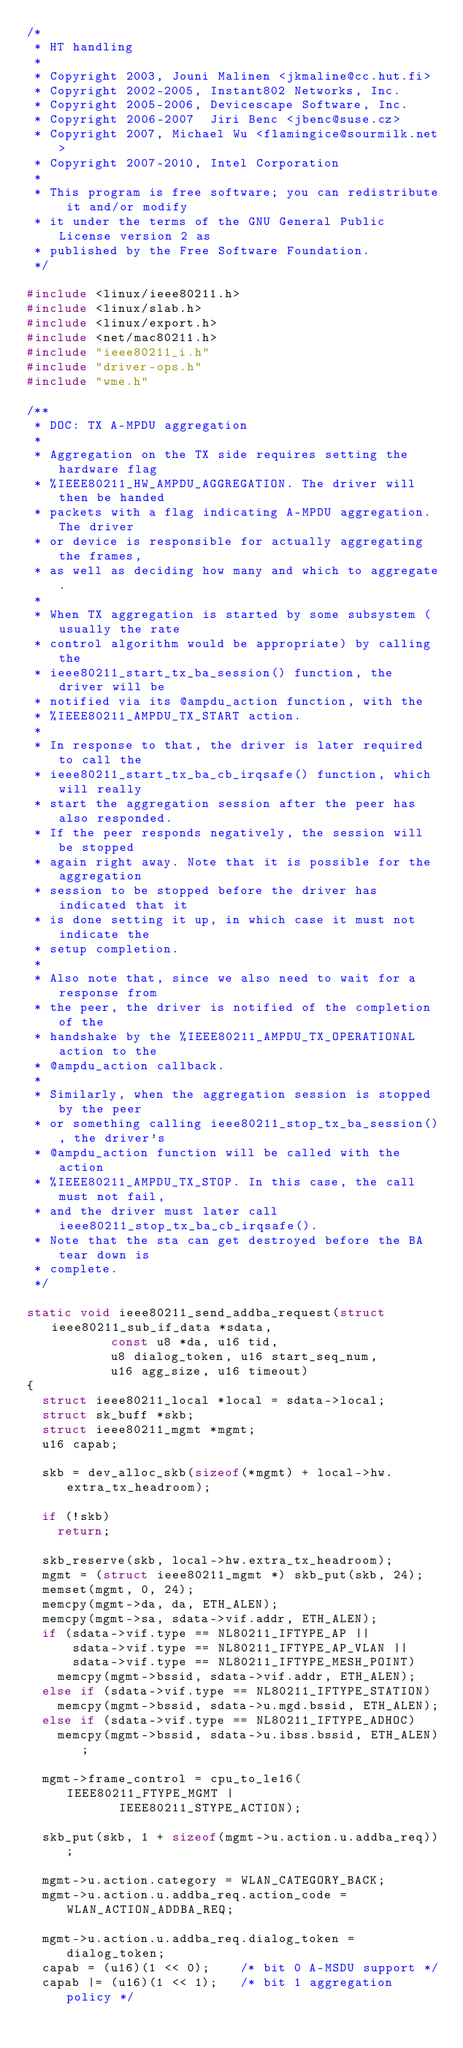<code> <loc_0><loc_0><loc_500><loc_500><_C_>/*
 * HT handling
 *
 * Copyright 2003, Jouni Malinen <jkmaline@cc.hut.fi>
 * Copyright 2002-2005, Instant802 Networks, Inc.
 * Copyright 2005-2006, Devicescape Software, Inc.
 * Copyright 2006-2007	Jiri Benc <jbenc@suse.cz>
 * Copyright 2007, Michael Wu <flamingice@sourmilk.net>
 * Copyright 2007-2010, Intel Corporation
 *
 * This program is free software; you can redistribute it and/or modify
 * it under the terms of the GNU General Public License version 2 as
 * published by the Free Software Foundation.
 */

#include <linux/ieee80211.h>
#include <linux/slab.h>
#include <linux/export.h>
#include <net/mac80211.h>
#include "ieee80211_i.h"
#include "driver-ops.h"
#include "wme.h"

/**
 * DOC: TX A-MPDU aggregation
 *
 * Aggregation on the TX side requires setting the hardware flag
 * %IEEE80211_HW_AMPDU_AGGREGATION. The driver will then be handed
 * packets with a flag indicating A-MPDU aggregation. The driver
 * or device is responsible for actually aggregating the frames,
 * as well as deciding how many and which to aggregate.
 *
 * When TX aggregation is started by some subsystem (usually the rate
 * control algorithm would be appropriate) by calling the
 * ieee80211_start_tx_ba_session() function, the driver will be
 * notified via its @ampdu_action function, with the
 * %IEEE80211_AMPDU_TX_START action.
 *
 * In response to that, the driver is later required to call the
 * ieee80211_start_tx_ba_cb_irqsafe() function, which will really
 * start the aggregation session after the peer has also responded.
 * If the peer responds negatively, the session will be stopped
 * again right away. Note that it is possible for the aggregation
 * session to be stopped before the driver has indicated that it
 * is done setting it up, in which case it must not indicate the
 * setup completion.
 *
 * Also note that, since we also need to wait for a response from
 * the peer, the driver is notified of the completion of the
 * handshake by the %IEEE80211_AMPDU_TX_OPERATIONAL action to the
 * @ampdu_action callback.
 *
 * Similarly, when the aggregation session is stopped by the peer
 * or something calling ieee80211_stop_tx_ba_session(), the driver's
 * @ampdu_action function will be called with the action
 * %IEEE80211_AMPDU_TX_STOP. In this case, the call must not fail,
 * and the driver must later call ieee80211_stop_tx_ba_cb_irqsafe().
 * Note that the sta can get destroyed before the BA tear down is
 * complete.
 */

static void ieee80211_send_addba_request(struct ieee80211_sub_if_data *sdata,
					 const u8 *da, u16 tid,
					 u8 dialog_token, u16 start_seq_num,
					 u16 agg_size, u16 timeout)
{
	struct ieee80211_local *local = sdata->local;
	struct sk_buff *skb;
	struct ieee80211_mgmt *mgmt;
	u16 capab;

	skb = dev_alloc_skb(sizeof(*mgmt) + local->hw.extra_tx_headroom);

	if (!skb)
		return;

	skb_reserve(skb, local->hw.extra_tx_headroom);
	mgmt = (struct ieee80211_mgmt *) skb_put(skb, 24);
	memset(mgmt, 0, 24);
	memcpy(mgmt->da, da, ETH_ALEN);
	memcpy(mgmt->sa, sdata->vif.addr, ETH_ALEN);
	if (sdata->vif.type == NL80211_IFTYPE_AP ||
	    sdata->vif.type == NL80211_IFTYPE_AP_VLAN ||
	    sdata->vif.type == NL80211_IFTYPE_MESH_POINT)
		memcpy(mgmt->bssid, sdata->vif.addr, ETH_ALEN);
	else if (sdata->vif.type == NL80211_IFTYPE_STATION)
		memcpy(mgmt->bssid, sdata->u.mgd.bssid, ETH_ALEN);
	else if (sdata->vif.type == NL80211_IFTYPE_ADHOC)
		memcpy(mgmt->bssid, sdata->u.ibss.bssid, ETH_ALEN);

	mgmt->frame_control = cpu_to_le16(IEEE80211_FTYPE_MGMT |
					  IEEE80211_STYPE_ACTION);

	skb_put(skb, 1 + sizeof(mgmt->u.action.u.addba_req));

	mgmt->u.action.category = WLAN_CATEGORY_BACK;
	mgmt->u.action.u.addba_req.action_code = WLAN_ACTION_ADDBA_REQ;

	mgmt->u.action.u.addba_req.dialog_token = dialog_token;
	capab = (u16)(1 << 0);		/* bit 0 A-MSDU support */
	capab |= (u16)(1 << 1);		/* bit 1 aggregation policy */</code> 